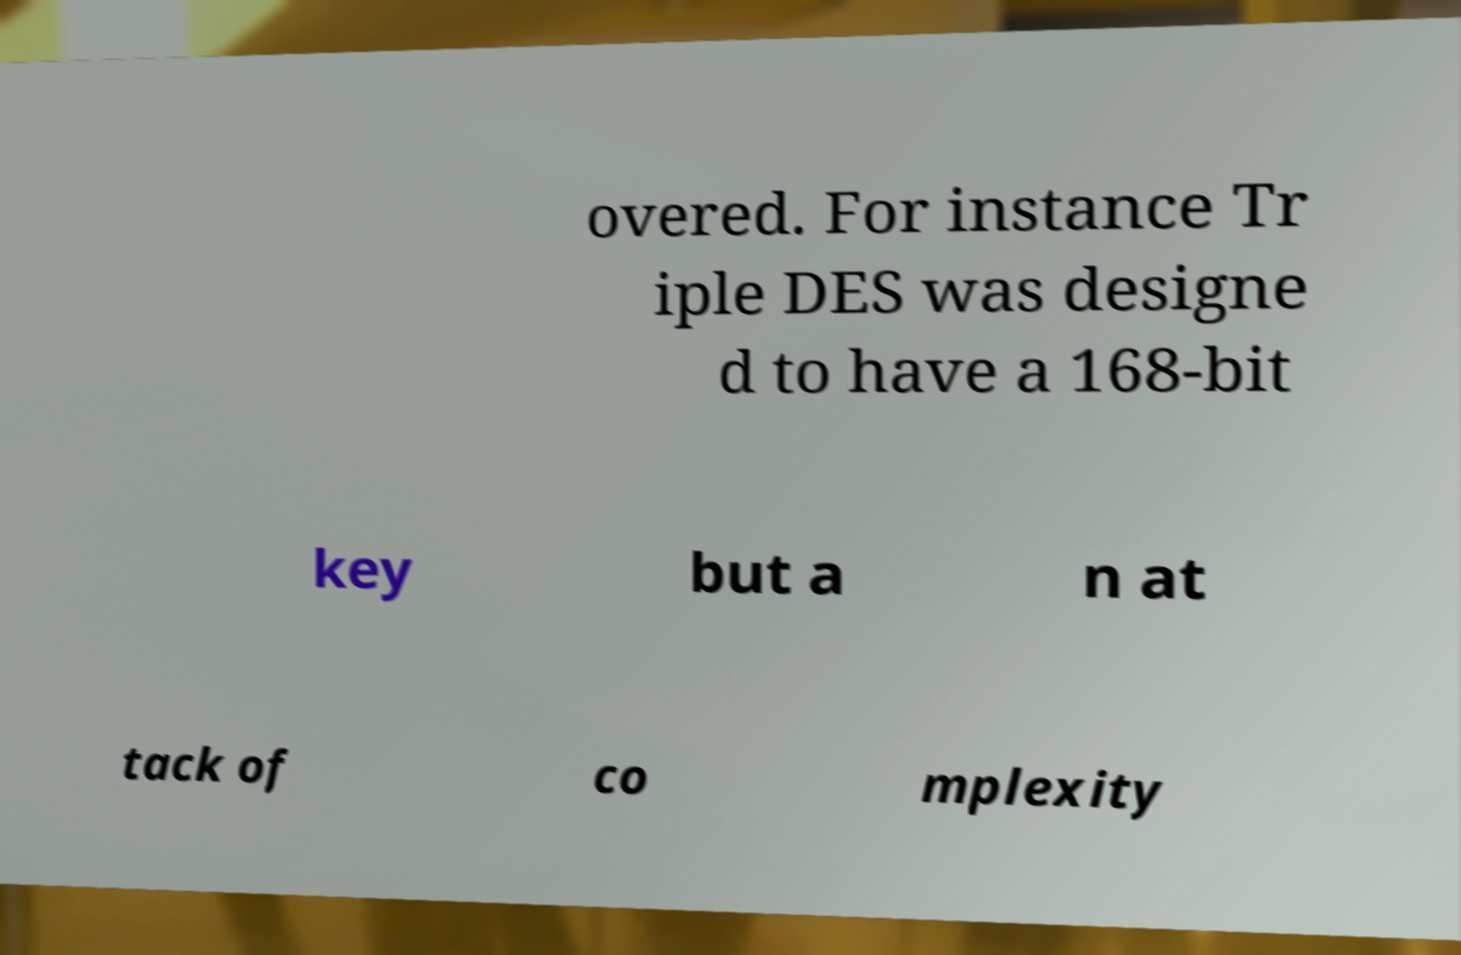What messages or text are displayed in this image? I need them in a readable, typed format. overed. For instance Tr iple DES was designe d to have a 168-bit key but a n at tack of co mplexity 